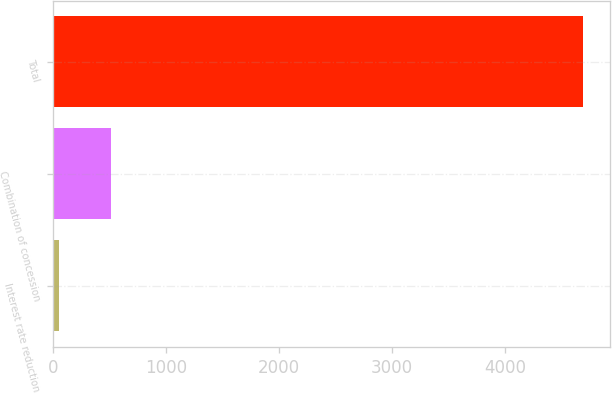Convert chart to OTSL. <chart><loc_0><loc_0><loc_500><loc_500><bar_chart><fcel>Interest rate reduction<fcel>Combination of concession<fcel>Total<nl><fcel>54<fcel>517.7<fcel>4691<nl></chart> 